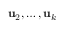Convert formula to latex. <formula><loc_0><loc_0><loc_500><loc_500>u _ { 2 } , \dots , u _ { k }</formula> 